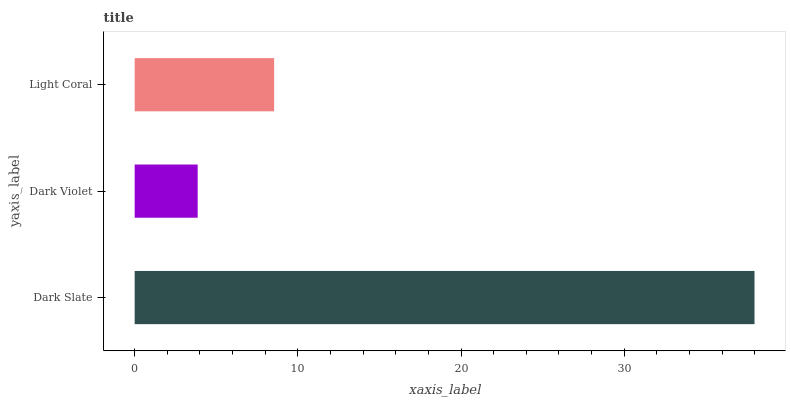Is Dark Violet the minimum?
Answer yes or no. Yes. Is Dark Slate the maximum?
Answer yes or no. Yes. Is Light Coral the minimum?
Answer yes or no. No. Is Light Coral the maximum?
Answer yes or no. No. Is Light Coral greater than Dark Violet?
Answer yes or no. Yes. Is Dark Violet less than Light Coral?
Answer yes or no. Yes. Is Dark Violet greater than Light Coral?
Answer yes or no. No. Is Light Coral less than Dark Violet?
Answer yes or no. No. Is Light Coral the high median?
Answer yes or no. Yes. Is Light Coral the low median?
Answer yes or no. Yes. Is Dark Violet the high median?
Answer yes or no. No. Is Dark Violet the low median?
Answer yes or no. No. 